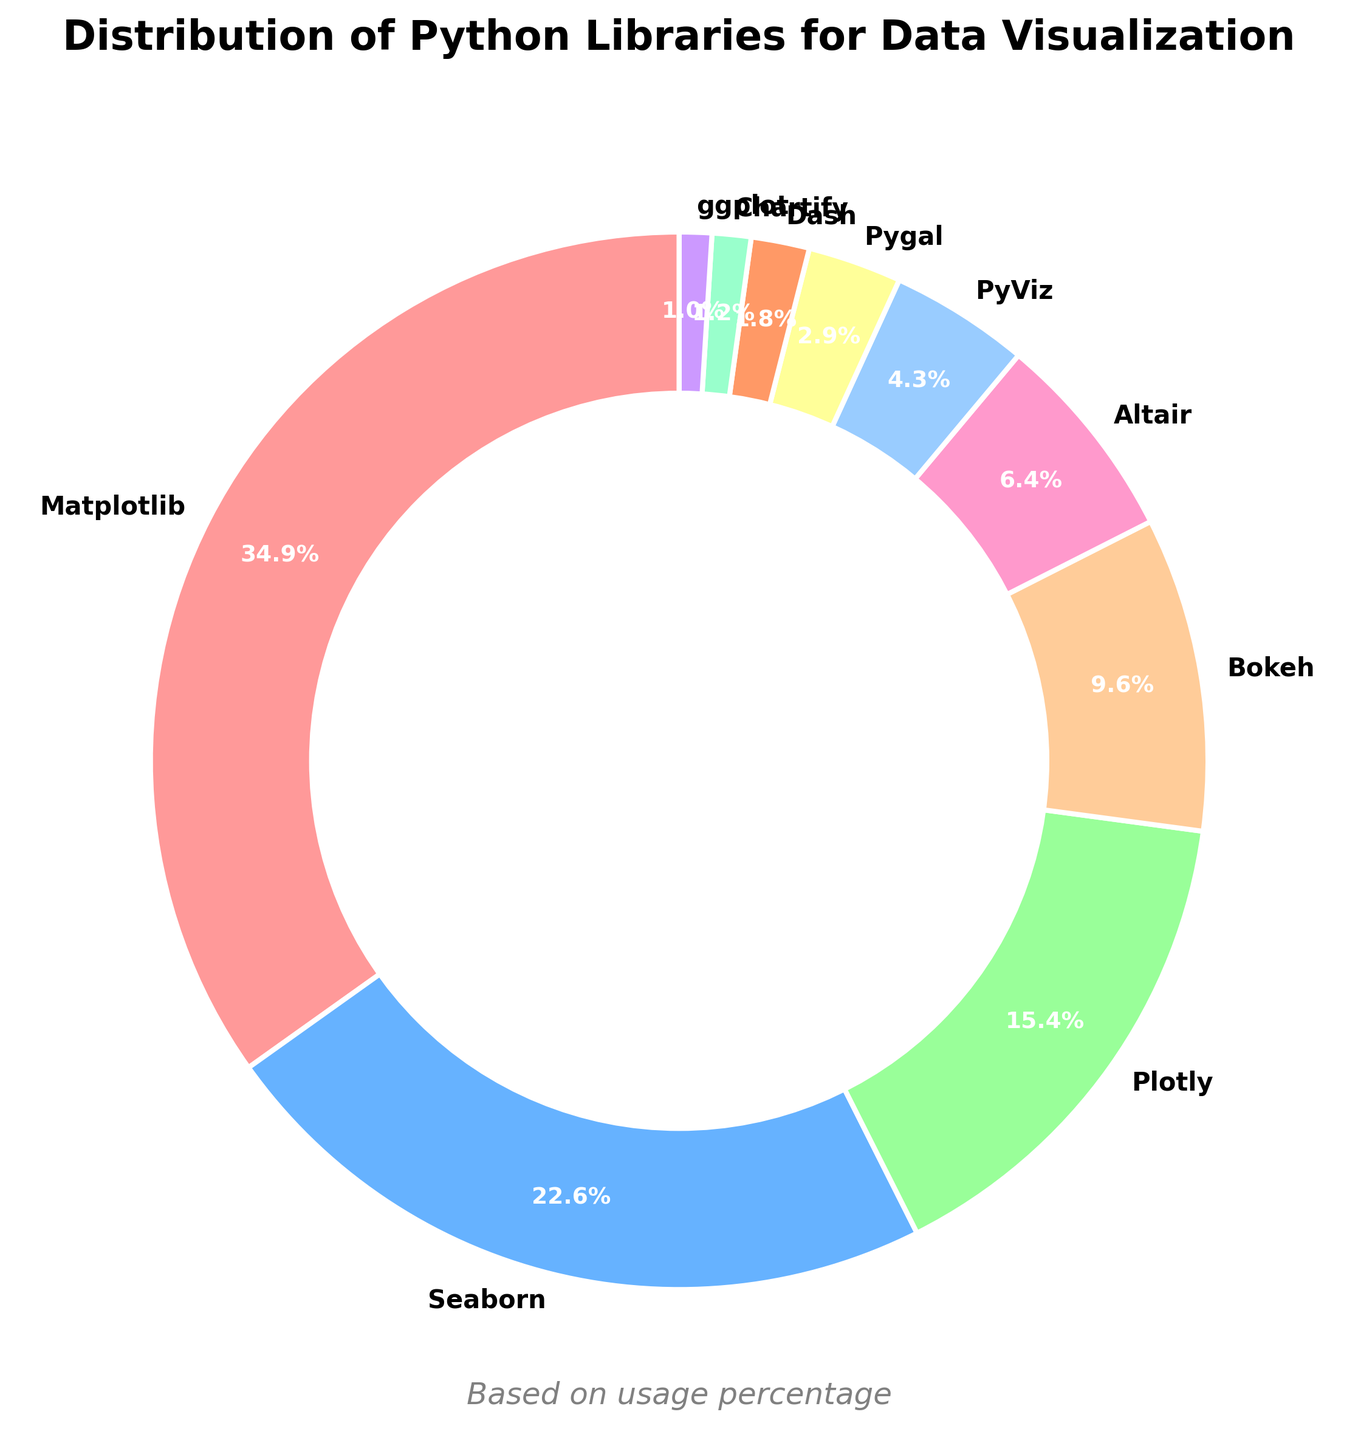What's the most used library for data visualization? The library with the largest percentage slice in the pie chart is the most used. By looking at the chart, we see that Matplotlib has the largest section, which means it has the highest usage percentage.
Answer: Matplotlib Which libraries have usage percentages greater than 20%? To find the libraries with more than 20% usage, we look at each slice of the pie chart and its corresponding label. The libraries with usage percentages greater than 20% are Matplotlib with 35.2% and Seaborn with 22.8%.
Answer: Matplotlib, Seaborn What is the combined usage percentage of Bokeh and Altair? To get the combined usage percentage, we add the usage percentages of Bokeh (9.7%) and Altair (6.5%). So, the combined usage is 9.7 + 6.5 = 16.2%.
Answer: 16.2% Which library uses a pinkish tone in the pie chart? By inspecting the colors of each slice in the pie chart and matching them to their labels, we can see which library has a pinkish-colored section. The pinkish tone is associated with Matplotlib.
Answer: Matplotlib What is the difference in usage percentage between Plotly and Dash? We find the usage percentages of Plotly and Dash, which are 15.6% and 1.8% respectively. Then we subtract the smaller percentage from the larger one: 15.6 - 1.8 = 13.8%.
Answer: 13.8% Are there any libraries with a usage percentage less than 5%? If so, which ones? To determine this, we look at each slice labeled with a percentage. Libraries with usage percentages less than 5% are PyViz (4.3%), Pygal (2.9%), Dash (1.8%), Chartify (1.2%), and ggplot (1.0%).
Answer: PyViz, Pygal, Dash, Chartify, ggplot What is the average usage percentage of Seaborn, Plotly, and Bokeh combined? First, sum the usage percentages of Seaborn, Plotly, and Bokeh: 22.8 + 15.6 + 9.7 = 48.1%. Next, divide this by the number of libraries (3): 48.1 / 3 = 16.03%.
Answer: 16.03% Which library has the smallest usage percentage, and what is it? By looking at the pie chart, the smallest slice with the least percentage corresponds to ggplot, which has a usage percentage of 1.0%.
Answer: ggplot, 1.0% Which two libraries combined have usage percentages closest to 30%? We need to test combinations of usage percentages to find the sum closest to 30%. By checking pairs:
- Altair (6.5%) + PyViz (4.3%) = 10.8%
- Altair (6.5%) + Dash (1.8%) = 8.3%
- Plotly (15.6%) + Pygal (2.9%) = 18.5%
- Plotly (15.6%) + Altair (6.5%) = 22.1%
- Seaborn (22.8%) + Altair (6.5%) = 29.3%
So, Seaborn and Altair combined have the percentage closest to 30%.
Answer: Seaborn, Altair, 29.3% What is the percentage point difference between the most and least used libraries? The most used library is Matplotlib with 35.2%, and the least used library is ggplot with 1.0%. The difference in percentage points is 35.2 - 1.0 = 34.2%.
Answer: 34.2% 